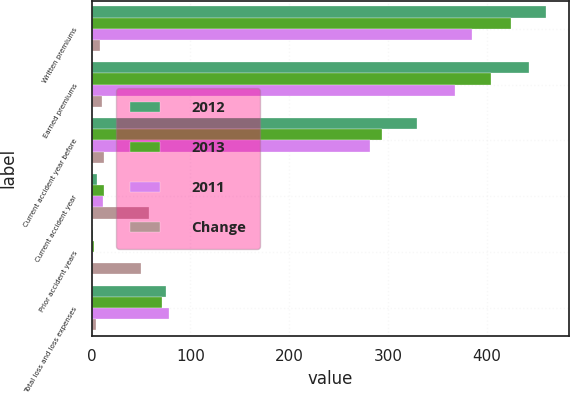Convert chart to OTSL. <chart><loc_0><loc_0><loc_500><loc_500><stacked_bar_chart><ecel><fcel>Written premiums<fcel>Earned premiums<fcel>Current accident year before<fcel>Current accident year<fcel>Prior accident years<fcel>Total loss and loss expenses<nl><fcel>2012<fcel>460<fcel>443<fcel>329<fcel>5<fcel>1<fcel>75.1<nl><fcel>2013<fcel>425<fcel>404<fcel>294<fcel>12<fcel>2<fcel>71<nl><fcel>2011<fcel>385<fcel>368<fcel>282<fcel>11<fcel>1<fcel>78.7<nl><fcel>Change<fcel>8<fcel>10<fcel>12<fcel>58<fcel>50<fcel>4.1<nl></chart> 